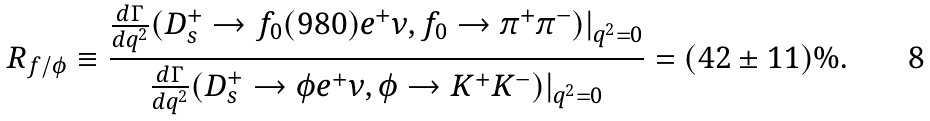<formula> <loc_0><loc_0><loc_500><loc_500>R _ { f / \phi } \equiv \frac { { \frac { d \Gamma } { d q ^ { 2 } } } ( D _ { s } ^ { + } \to f _ { 0 } ( 9 8 0 ) e ^ { + } \nu , f _ { 0 } \to \pi ^ { + } \pi ^ { - } ) | _ { q ^ { 2 } = 0 } } { { \frac { d \Gamma } { d q ^ { 2 } } } ( D _ { s } ^ { + } \to \phi e ^ { + } \nu , \phi \to K ^ { + } K ^ { - } ) | _ { q ^ { 2 } = 0 } } = ( 4 2 \pm 1 1 ) \% .</formula> 